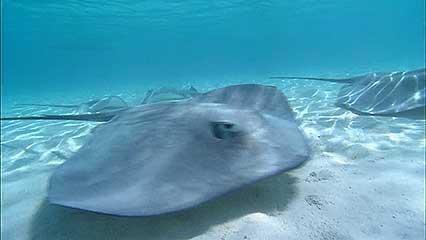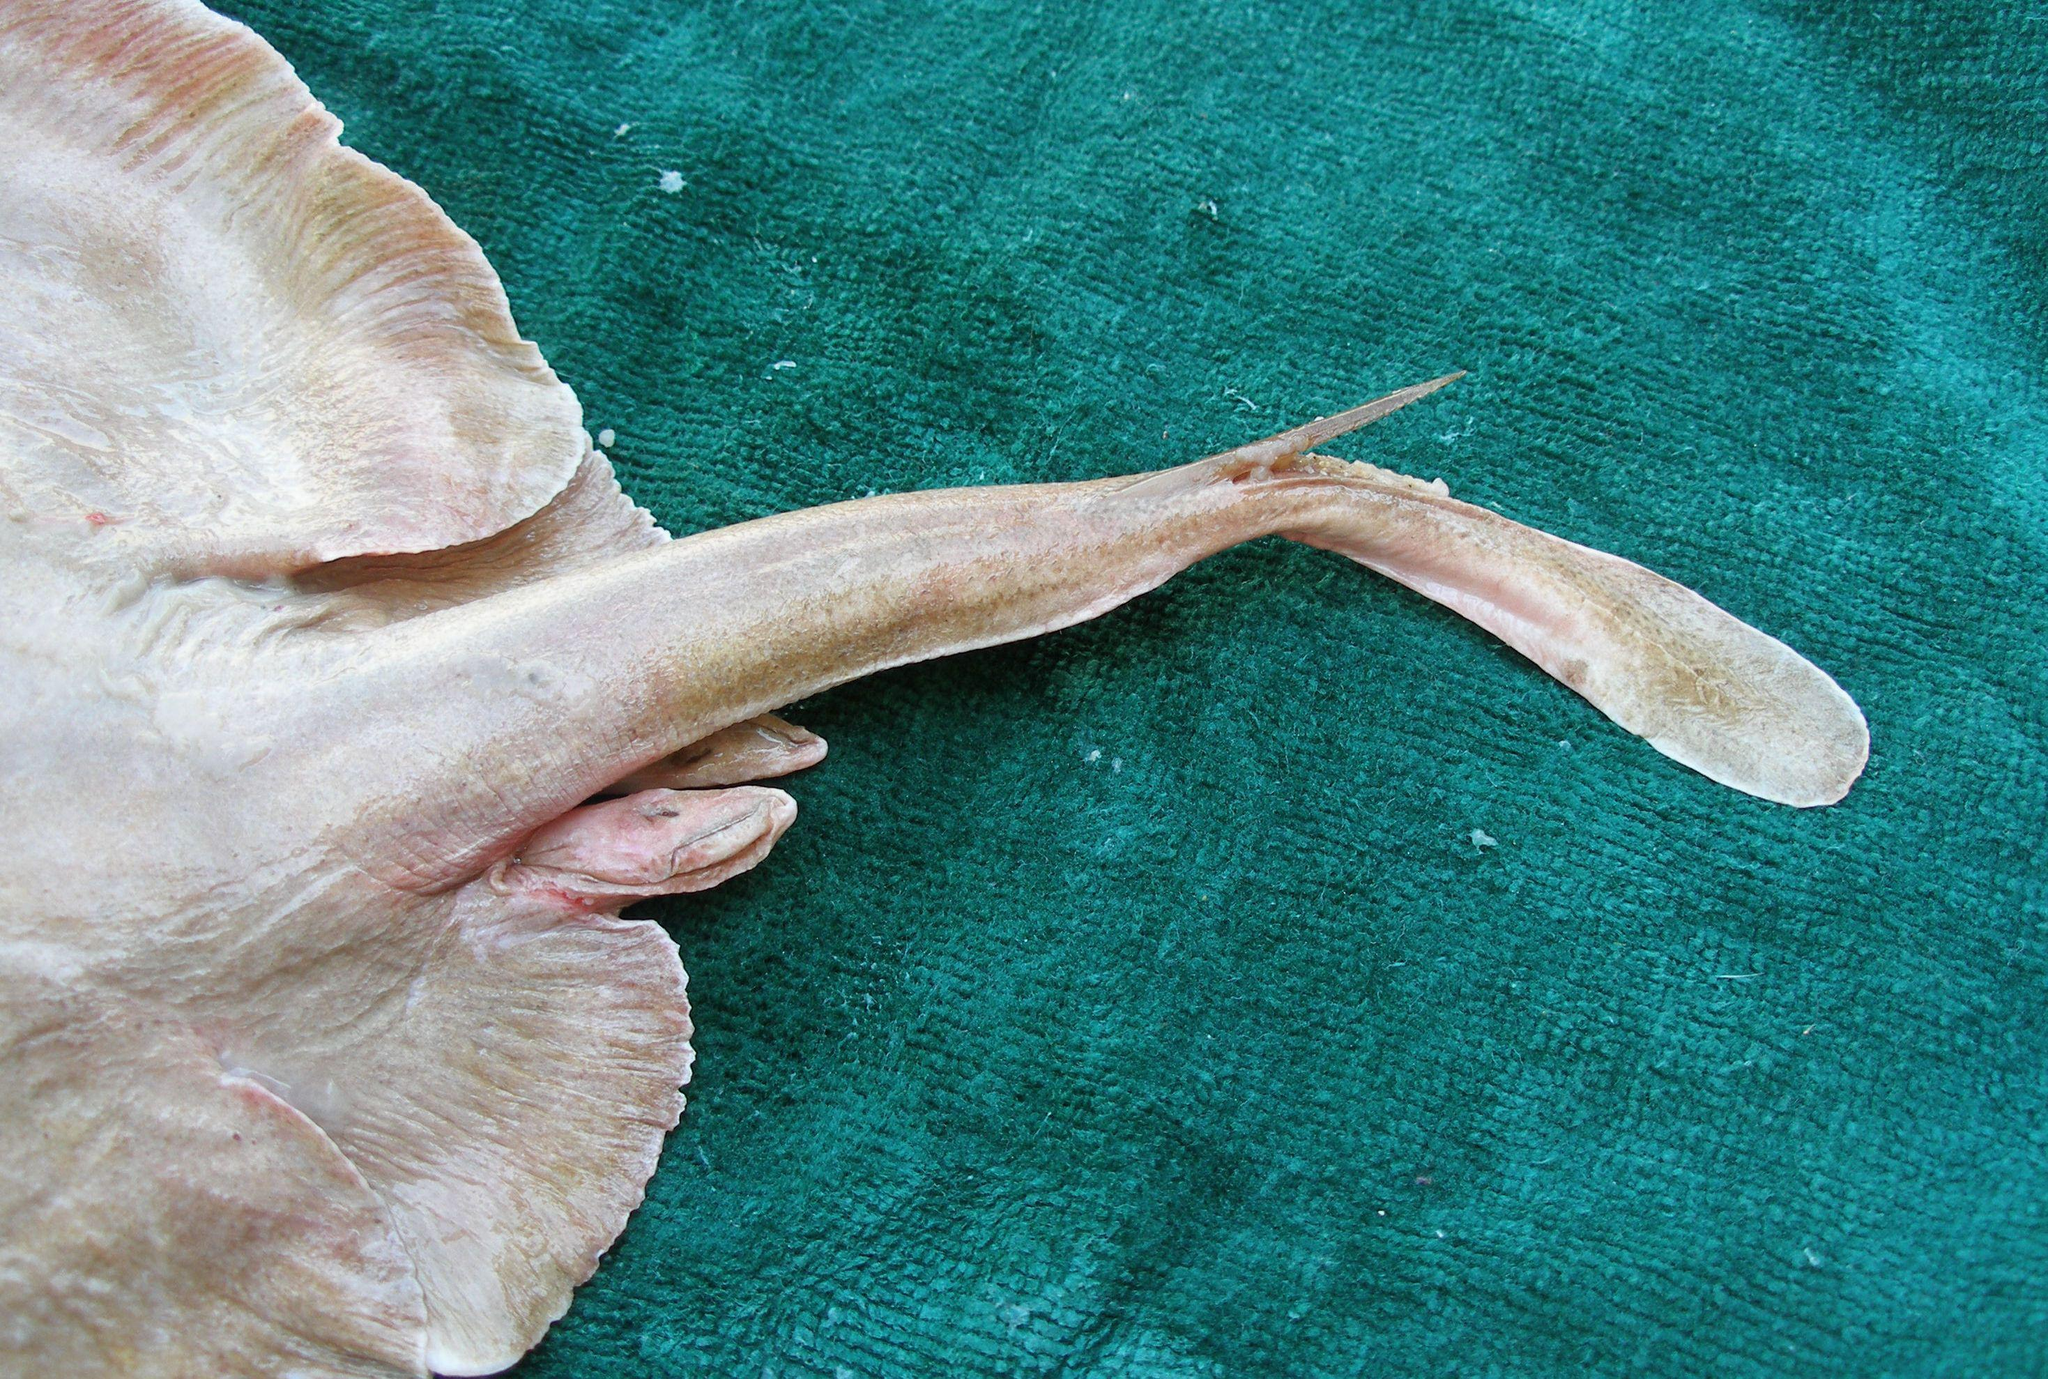The first image is the image on the left, the second image is the image on the right. Given the left and right images, does the statement "The animal in the image on the left is just above the seafloor." hold true? Answer yes or no. Yes. 